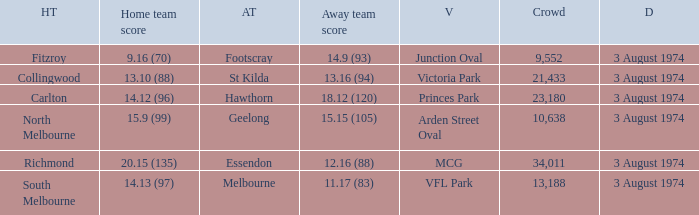Which Home team has a Venue of arden street oval? North Melbourne. 